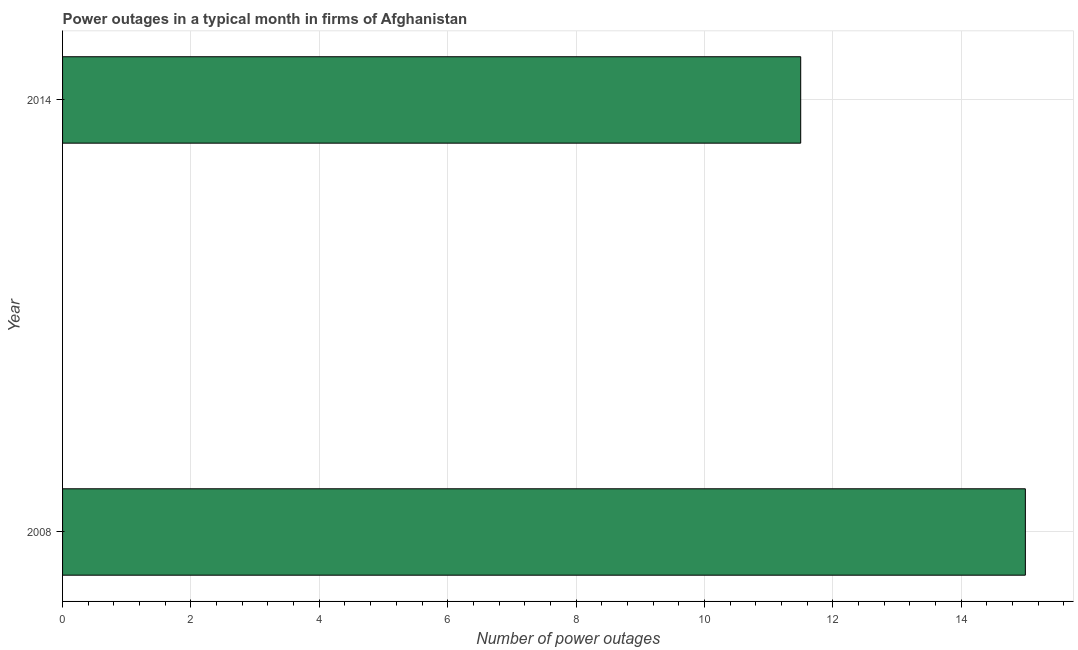Does the graph contain any zero values?
Your response must be concise. No. Does the graph contain grids?
Your answer should be very brief. Yes. What is the title of the graph?
Keep it short and to the point. Power outages in a typical month in firms of Afghanistan. What is the label or title of the X-axis?
Your answer should be very brief. Number of power outages. Across all years, what is the minimum number of power outages?
Offer a very short reply. 11.5. In which year was the number of power outages maximum?
Keep it short and to the point. 2008. In which year was the number of power outages minimum?
Your answer should be compact. 2014. What is the sum of the number of power outages?
Ensure brevity in your answer.  26.5. What is the difference between the number of power outages in 2008 and 2014?
Provide a succinct answer. 3.5. What is the average number of power outages per year?
Provide a succinct answer. 13.25. What is the median number of power outages?
Keep it short and to the point. 13.25. Do a majority of the years between 2014 and 2008 (inclusive) have number of power outages greater than 8 ?
Provide a succinct answer. No. What is the ratio of the number of power outages in 2008 to that in 2014?
Give a very brief answer. 1.3. In how many years, is the number of power outages greater than the average number of power outages taken over all years?
Provide a succinct answer. 1. What is the difference between two consecutive major ticks on the X-axis?
Make the answer very short. 2. Are the values on the major ticks of X-axis written in scientific E-notation?
Provide a short and direct response. No. What is the Number of power outages of 2008?
Offer a terse response. 15. What is the difference between the Number of power outages in 2008 and 2014?
Your response must be concise. 3.5. What is the ratio of the Number of power outages in 2008 to that in 2014?
Make the answer very short. 1.3. 